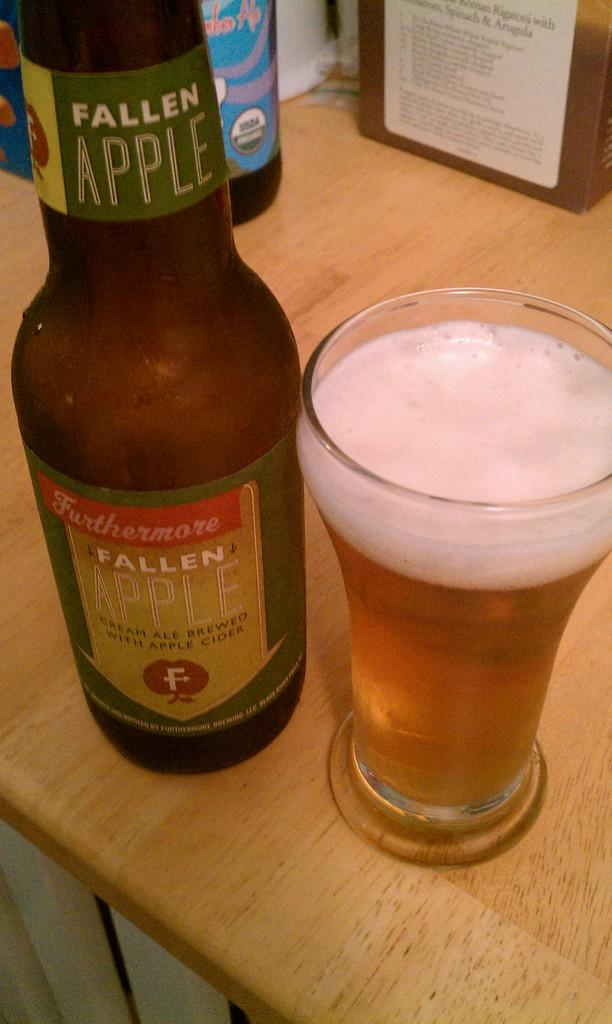<image>
Describe the image concisely. A glass bottle of Fallen Apple cider with a full glass next to it. 